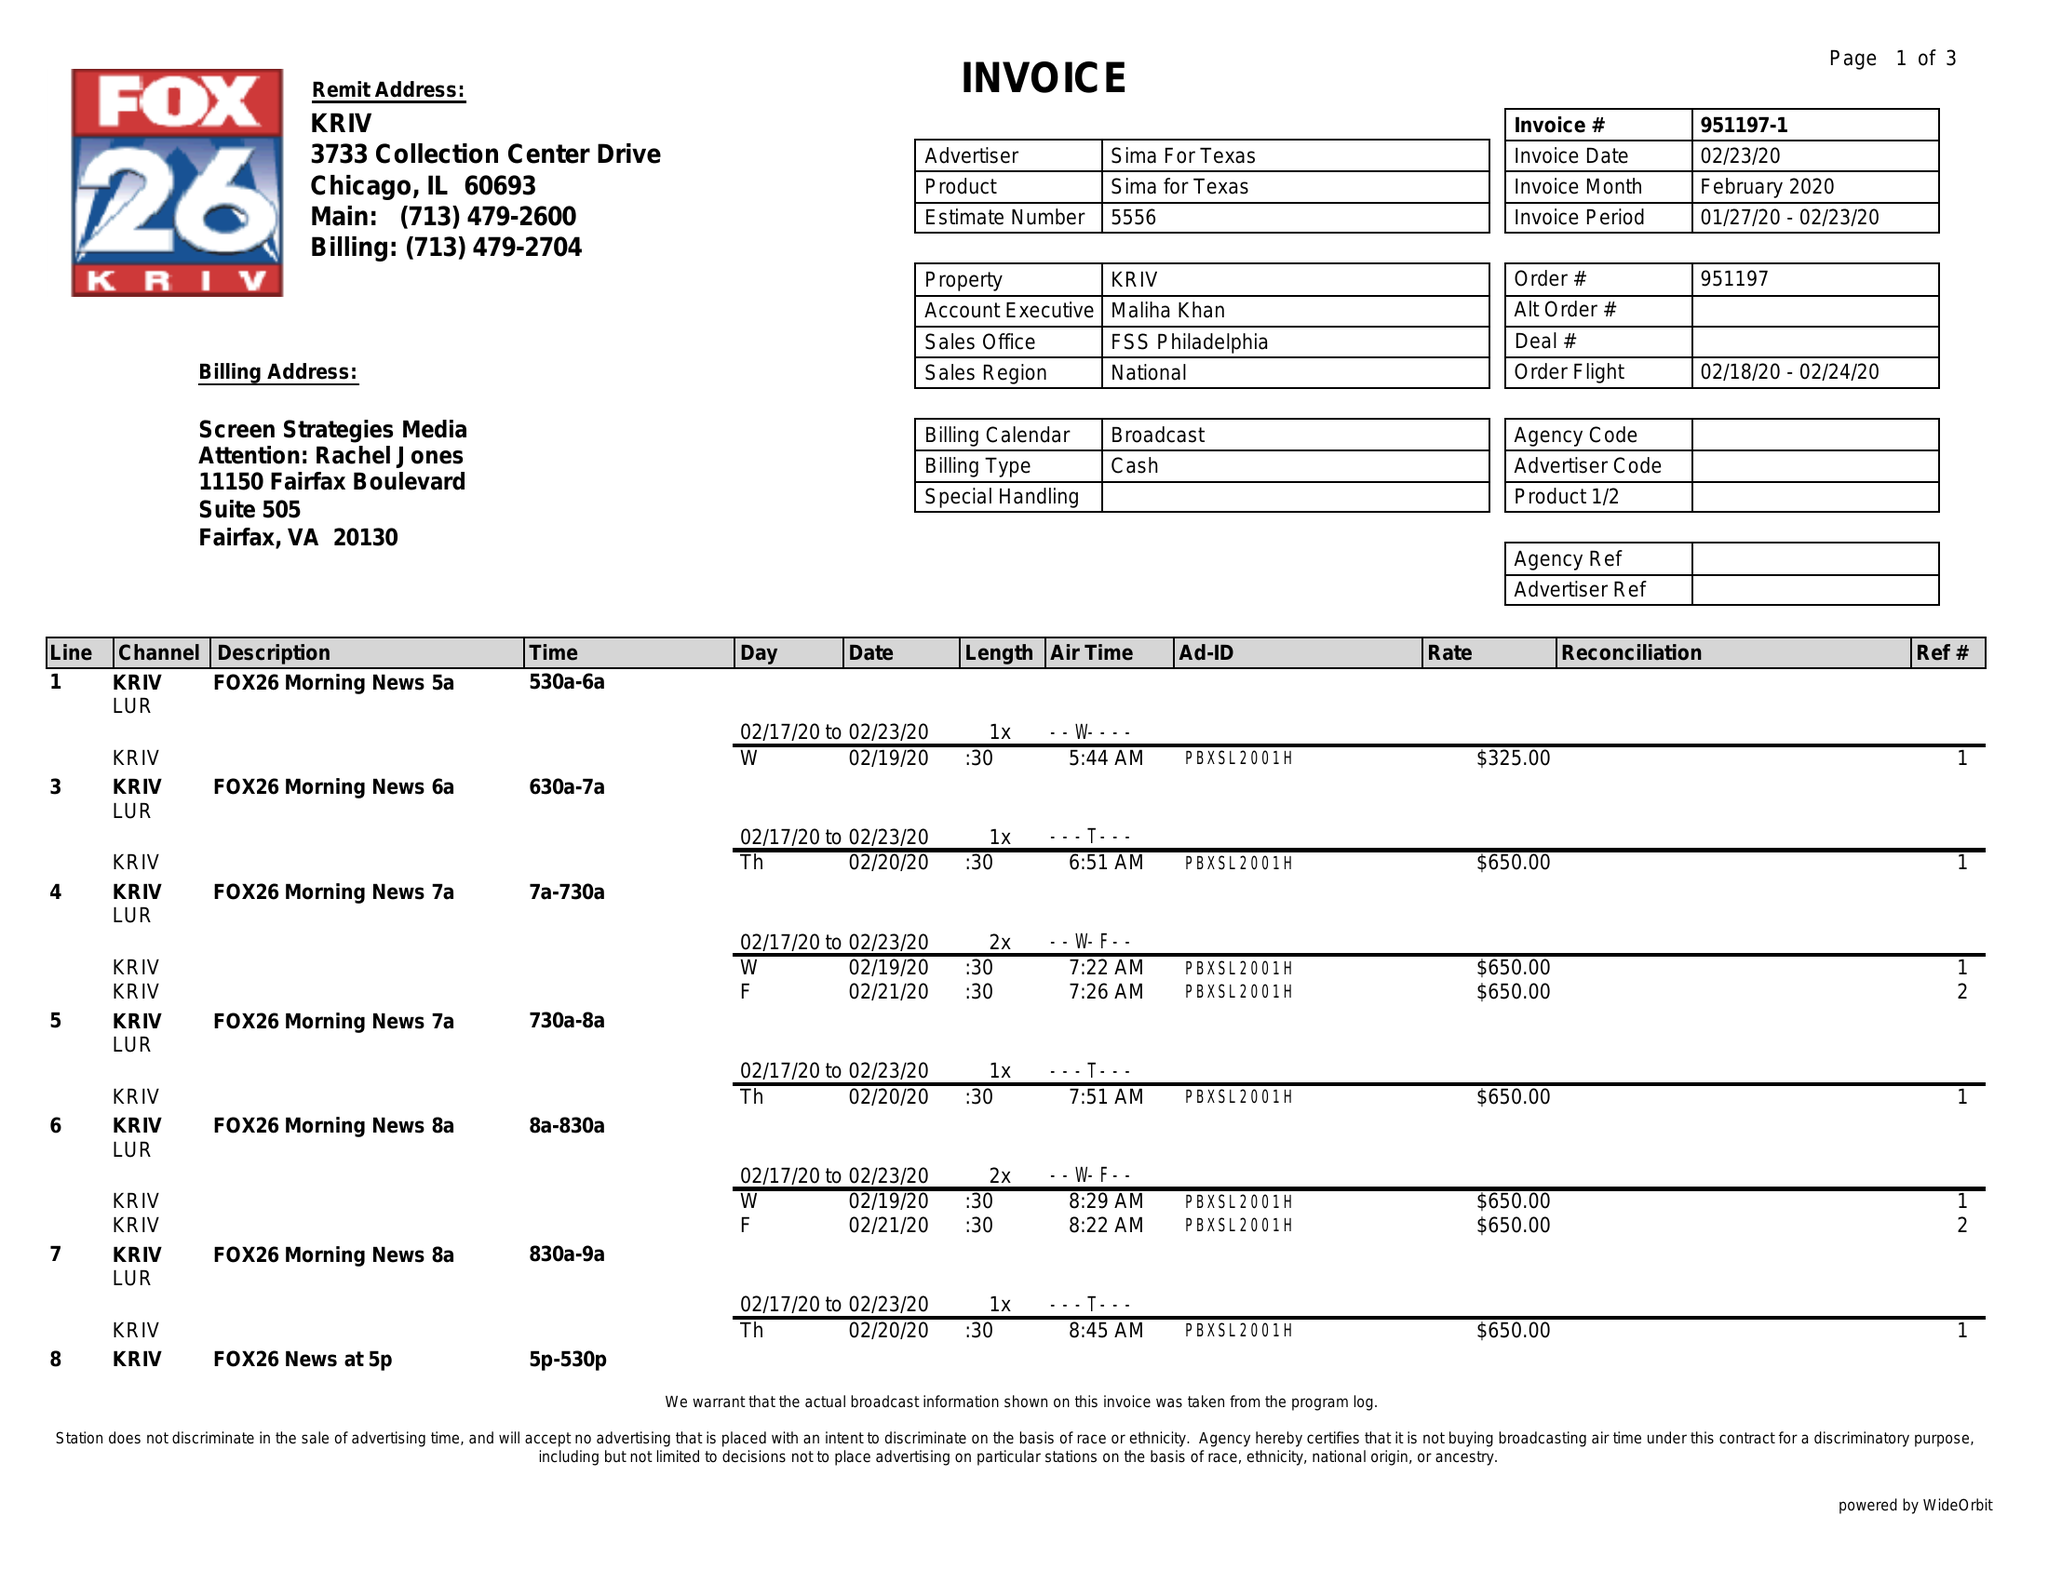What is the value for the flight_to?
Answer the question using a single word or phrase. 02/24/20 